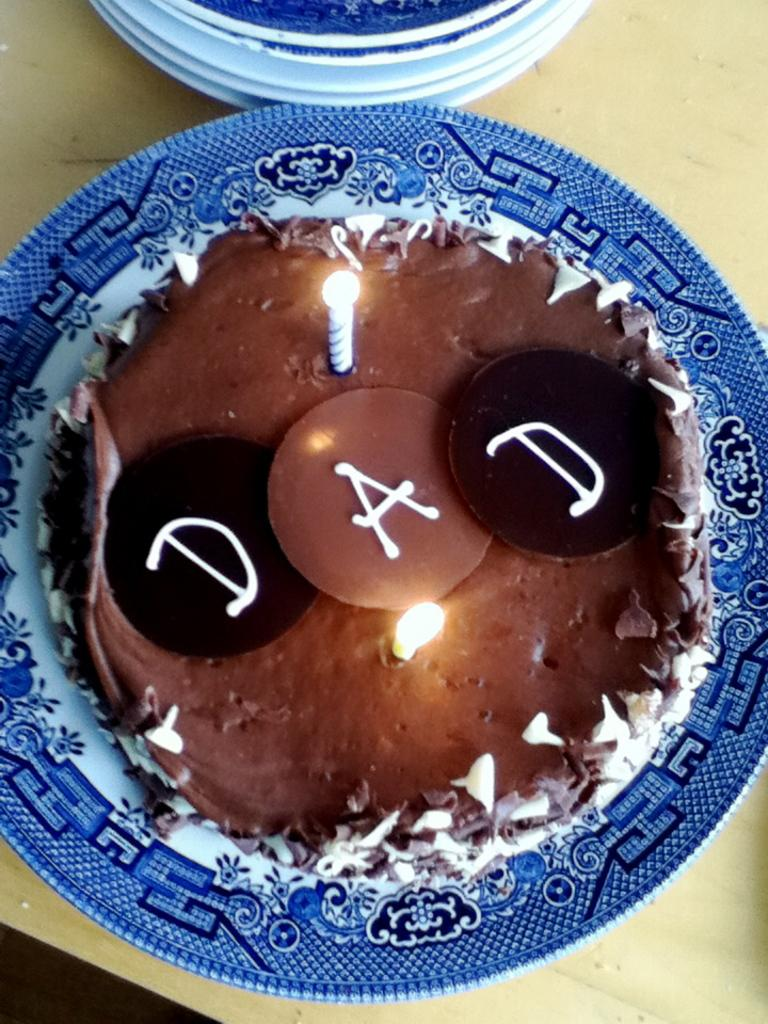What is the main object on the plate in the image? There is a cake on a plate in the image. What is written or depicted on the cake? There is text on the cake. What is used to provide light or decoration on the cake? There are candles on the cake. What can be seen in the background of the image? There are plates visible in the background of the image. What piece of furniture is the cake placed on? There is a table in the image. What type of quartz can be seen in the image? There is no quartz present in the image. What thing is being celebrated with the cake in the image? The image does not provide information about what the cake is celebrating, so we cannot determine the specific thing being celebrated. 